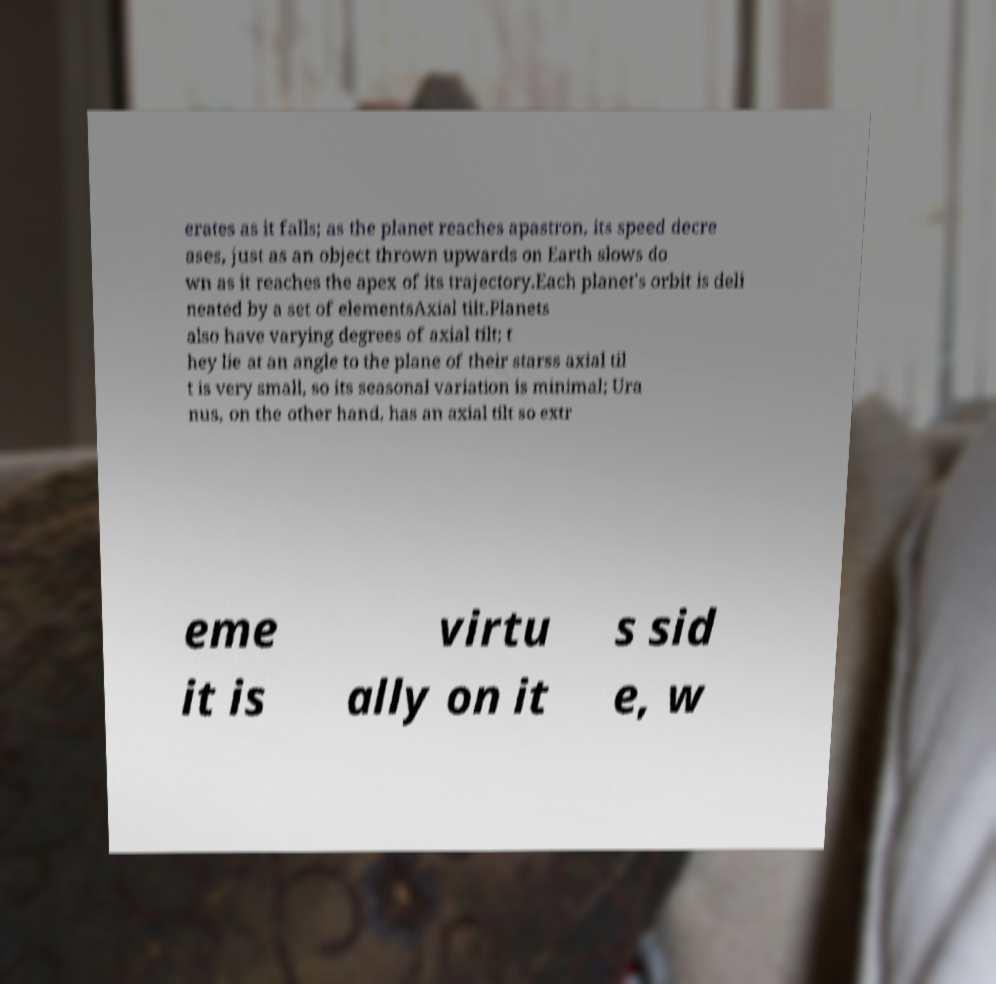Please identify and transcribe the text found in this image. erates as it falls; as the planet reaches apastron, its speed decre ases, just as an object thrown upwards on Earth slows do wn as it reaches the apex of its trajectory.Each planet's orbit is deli neated by a set of elementsAxial tilt.Planets also have varying degrees of axial tilt; t hey lie at an angle to the plane of their starss axial til t is very small, so its seasonal variation is minimal; Ura nus, on the other hand, has an axial tilt so extr eme it is virtu ally on it s sid e, w 